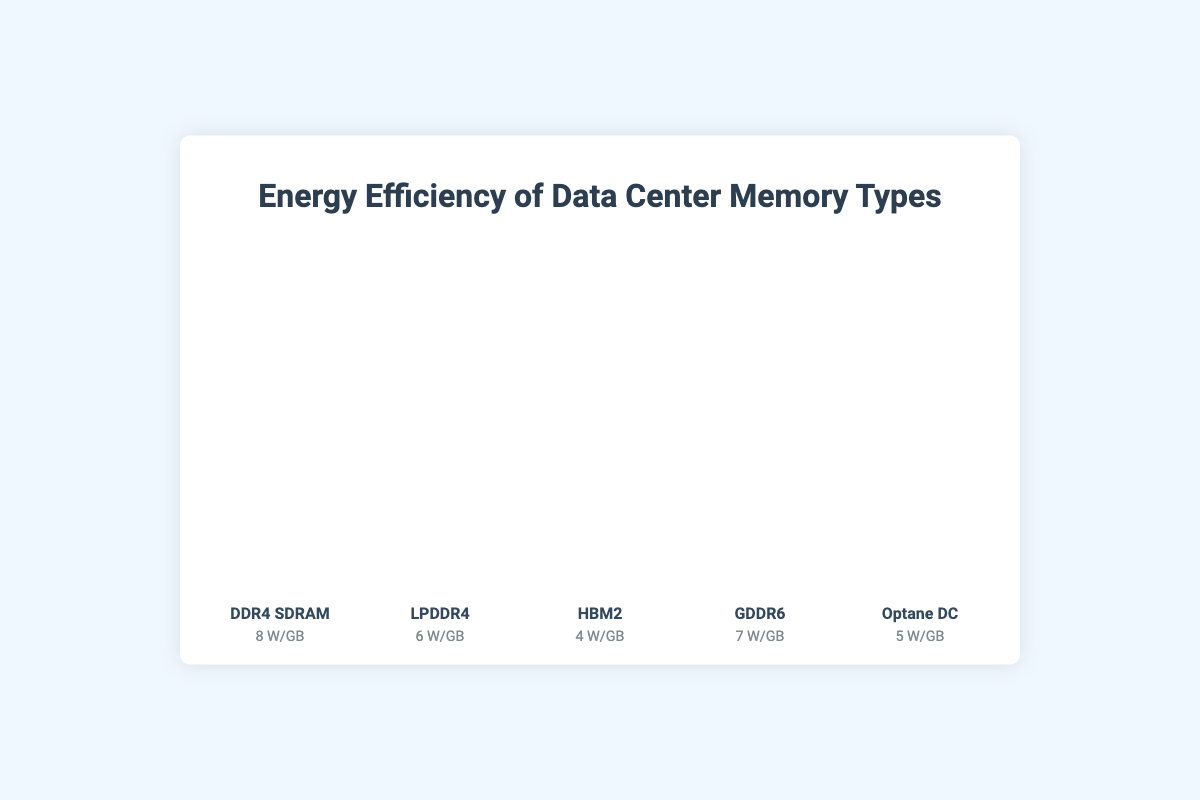Which memory type has the highest energy efficiency? By looking at the figure, we see that each memory type’s energy efficiency is represented by the number of icons, and HBM2 has the fewest icons. This indicates that HBM2 has the highest energy efficiency.
Answer: HBM2 Which memory type uses the most energy per gigabyte? The memory type with the most icons represents the highest energy consumption. DDR4 SDRAM has the most icons, indicating it uses the most energy per gigabyte.
Answer: DDR4 SDRAM How much more efficient is HBM2 compared to GDDR6? To find the difference, we subtract the energy efficiency value of HBM2 (4 W/GB) from GDDR6 (7 W/GB).
Answer: 3 W/GB Which memory types have energy efficiencies less efficient than 6 W/GB? We need to look for all memory types with more than 6 icons. DDR4 SDRAM and GDDR6 use more than 6 W/GB.
Answer: DDR4 SDRAM, GDDR6 What is the combined total energy efficiency of LPDDR4 and Optane DC? Add the energy efficiency values of LPDDR4 (6 W/GB) and Optane DC (5 W/GB). The combined value is 6 + 5 = 11 W/GB.
Answer: 11 W/GB By how much is GDDR6 more efficient than DDR4 SDRAM? By subtracting the energy efficiency value of GDDR6 (7 W/GB) from DDR4 SDRAM (8 W/GB), we get 8 - 7 = 1 W/GB.
Answer: 1 W/GB Which memory types have an efficiency rating of 5 W/GB or lower? Look for all memory types with 5 or fewer icons in the plot. These are HBM2 and Optane DC.
Answer: HBM2, Optane DC 